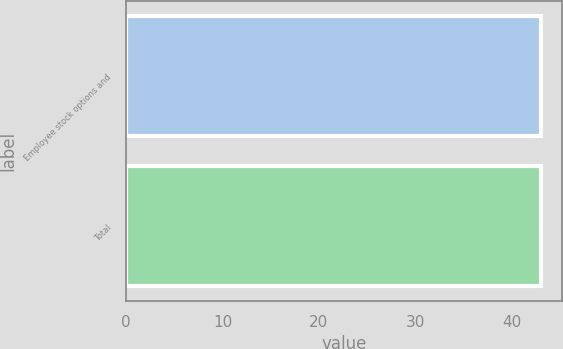Convert chart. <chart><loc_0><loc_0><loc_500><loc_500><bar_chart><fcel>Employee stock options and<fcel>Total<nl><fcel>43<fcel>43.1<nl></chart> 